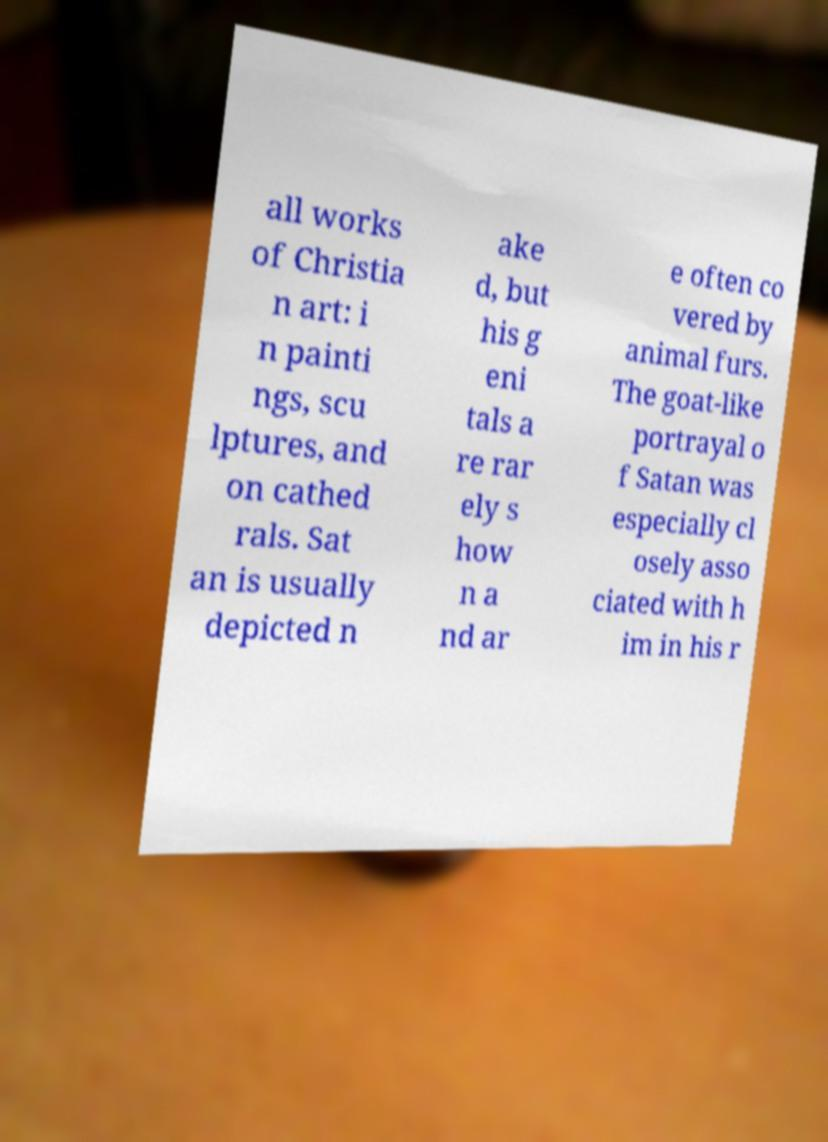Could you extract and type out the text from this image? all works of Christia n art: i n painti ngs, scu lptures, and on cathed rals. Sat an is usually depicted n ake d, but his g eni tals a re rar ely s how n a nd ar e often co vered by animal furs. The goat-like portrayal o f Satan was especially cl osely asso ciated with h im in his r 